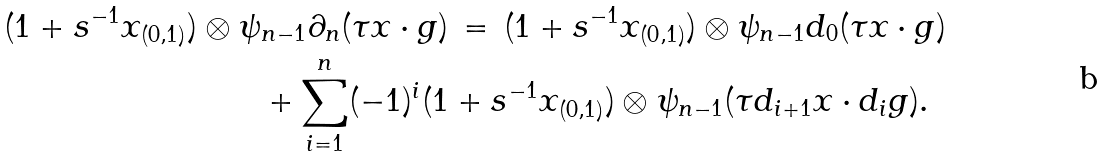<formula> <loc_0><loc_0><loc_500><loc_500>( 1 + s ^ { - 1 } x _ { ( 0 , 1 ) } ) \otimes \psi & _ { n - 1 } \partial _ { n } ( \tau x \cdot g ) \, = \, ( 1 + s ^ { - 1 } x _ { ( 0 , 1 ) } ) \otimes \psi _ { n - 1 } d _ { 0 } ( \tau x \cdot g ) \\ & + \sum _ { i = 1 } ^ { n } ( - 1 ) ^ { i } ( 1 + s ^ { - 1 } x _ { ( 0 , 1 ) } ) \otimes \psi _ { n - 1 } ( \tau d _ { i + 1 } x \cdot d _ { i } g ) .</formula> 